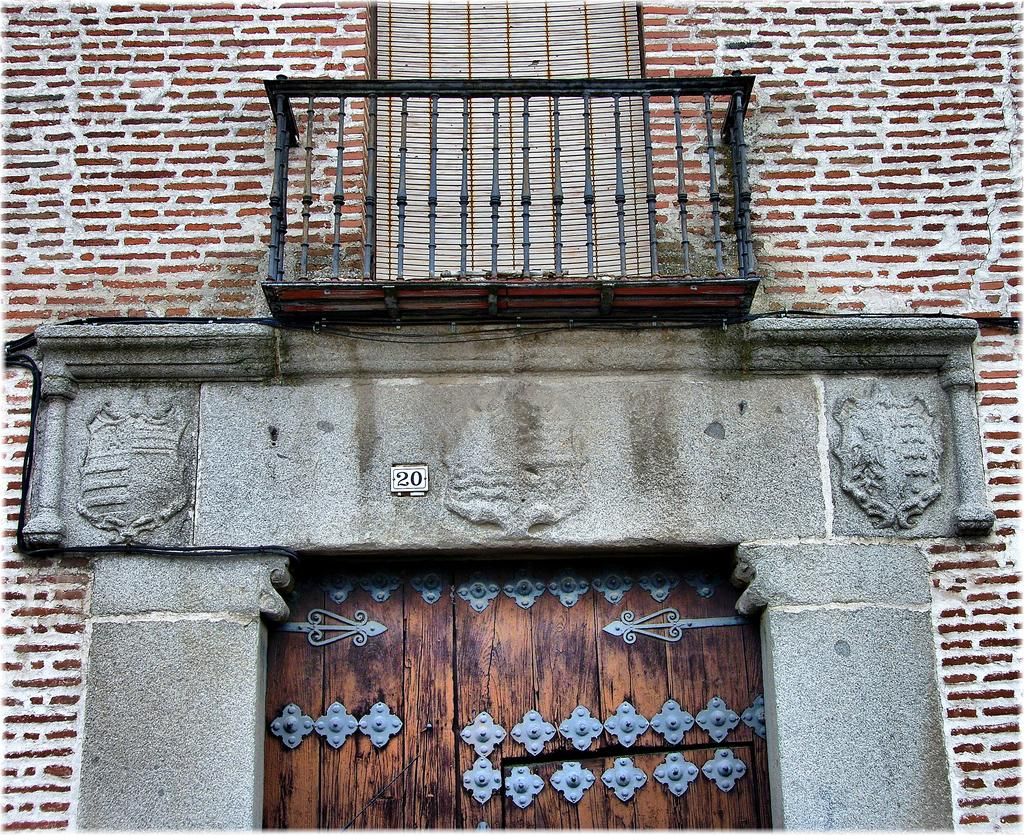What type of structure is visible in the image? There is a building in the image. What are the main features of the building? The building has walls, an iron grill, doors, and a name plate. What type of berry is growing on the stage in the image? There is no stage or berry present in the image. The image only features a building with specific features. 